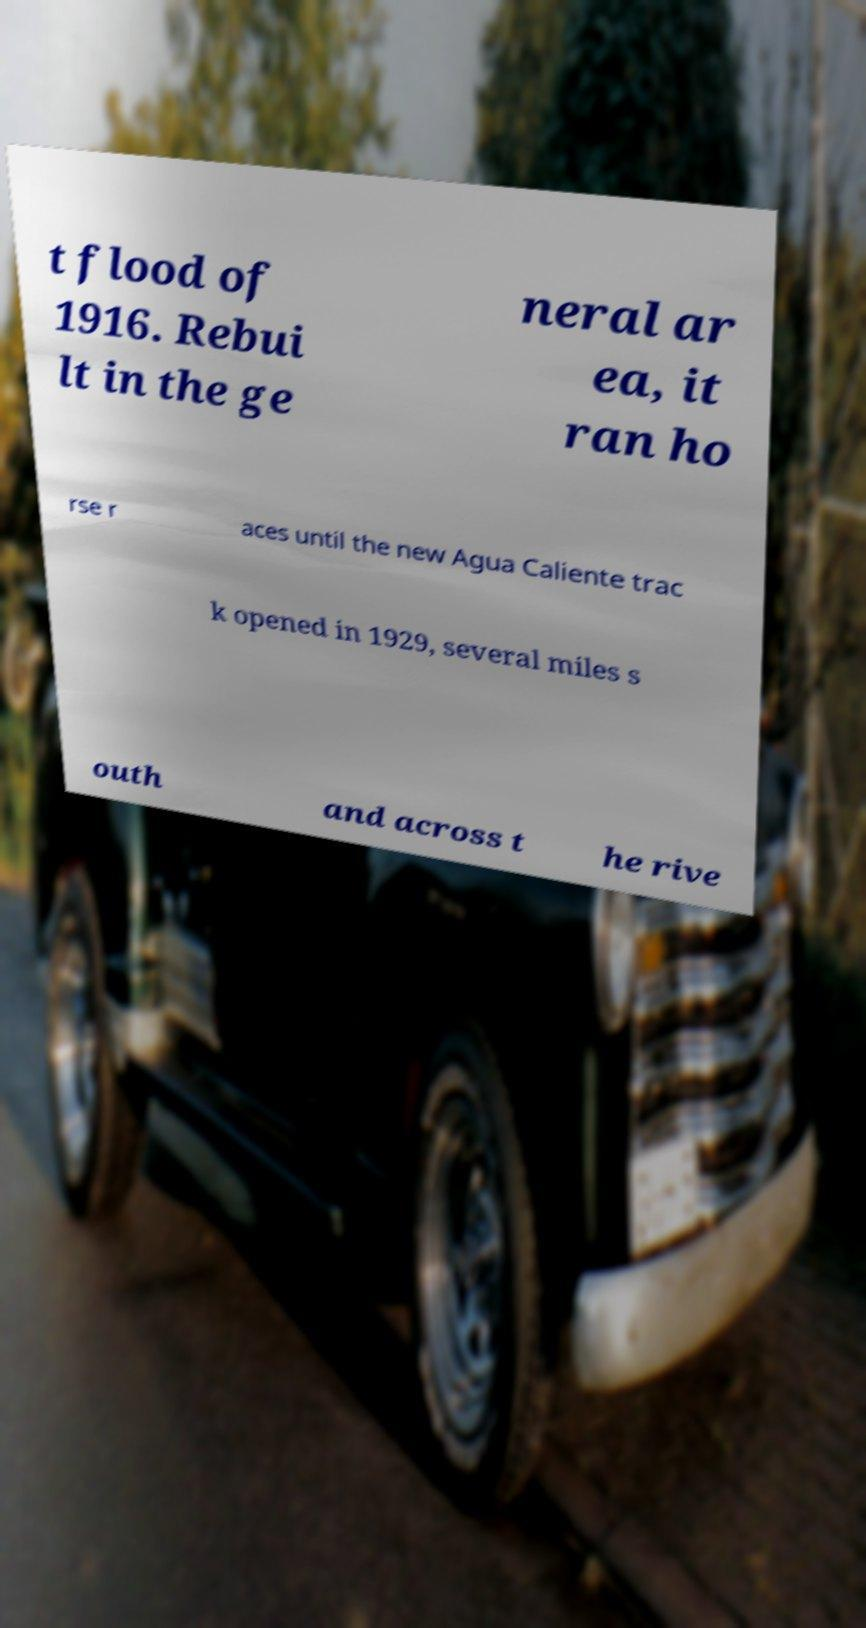I need the written content from this picture converted into text. Can you do that? t flood of 1916. Rebui lt in the ge neral ar ea, it ran ho rse r aces until the new Agua Caliente trac k opened in 1929, several miles s outh and across t he rive 